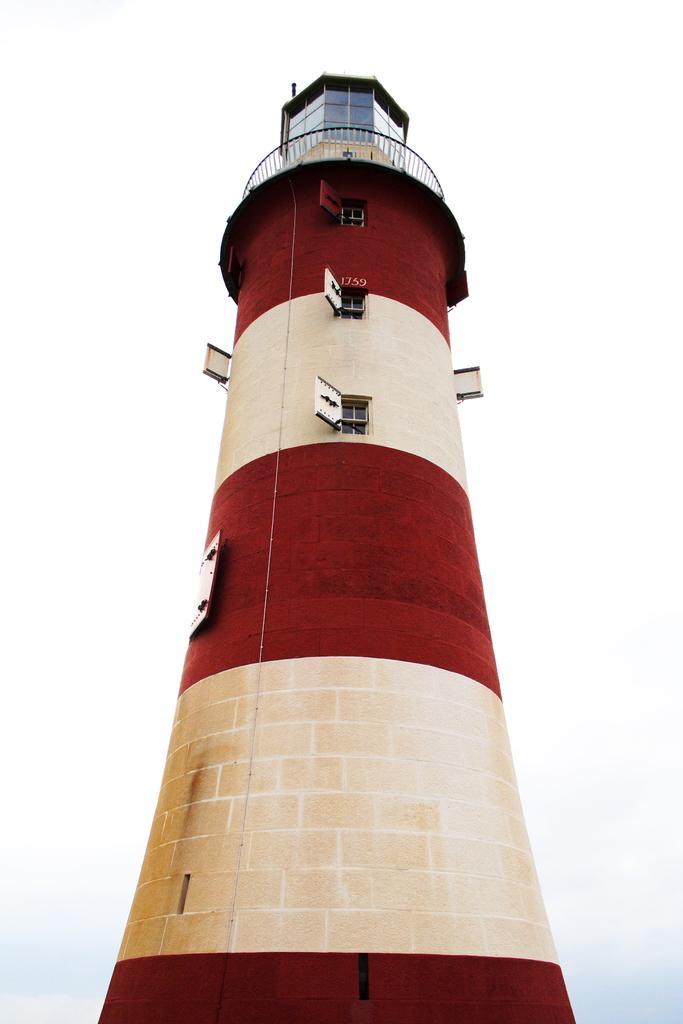Please provide a concise description of this image. In the picture we can see light house. 